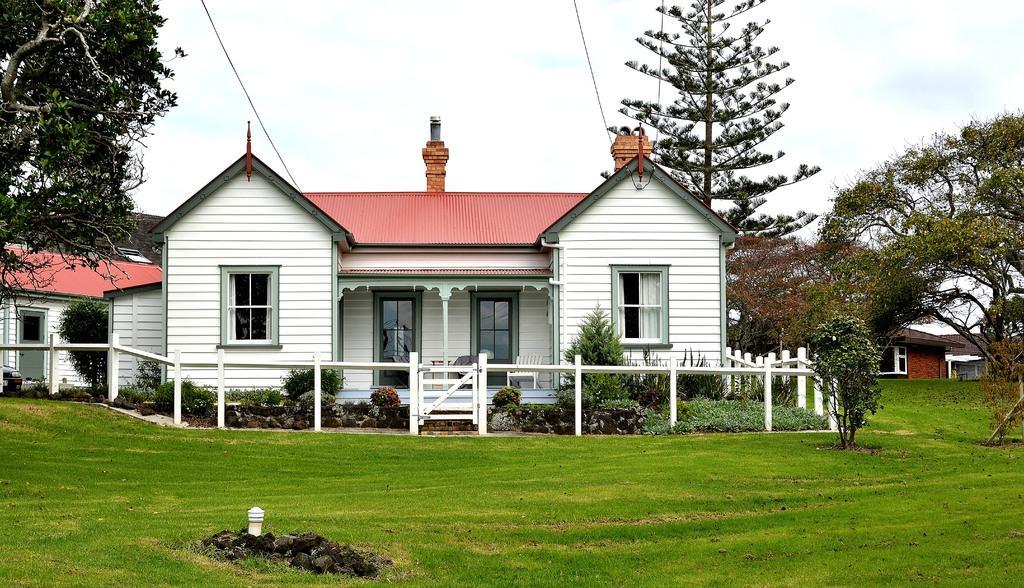In one or two sentences, can you explain what this image depicts? This looks like a house with the windows and doors. I can see the trees, plants and bushes. Here is the grass. This looks like a wooden fence. Here is a wooden gate. In the background, I can see another small house with a window. 